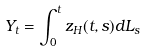Convert formula to latex. <formula><loc_0><loc_0><loc_500><loc_500>Y _ { t } = \int _ { 0 } ^ { t } z _ { H } ( t , s ) d L _ { s }</formula> 